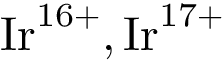<formula> <loc_0><loc_0><loc_500><loc_500>{ I r } ^ { 1 6 + } , { I r } ^ { 1 7 + }</formula> 